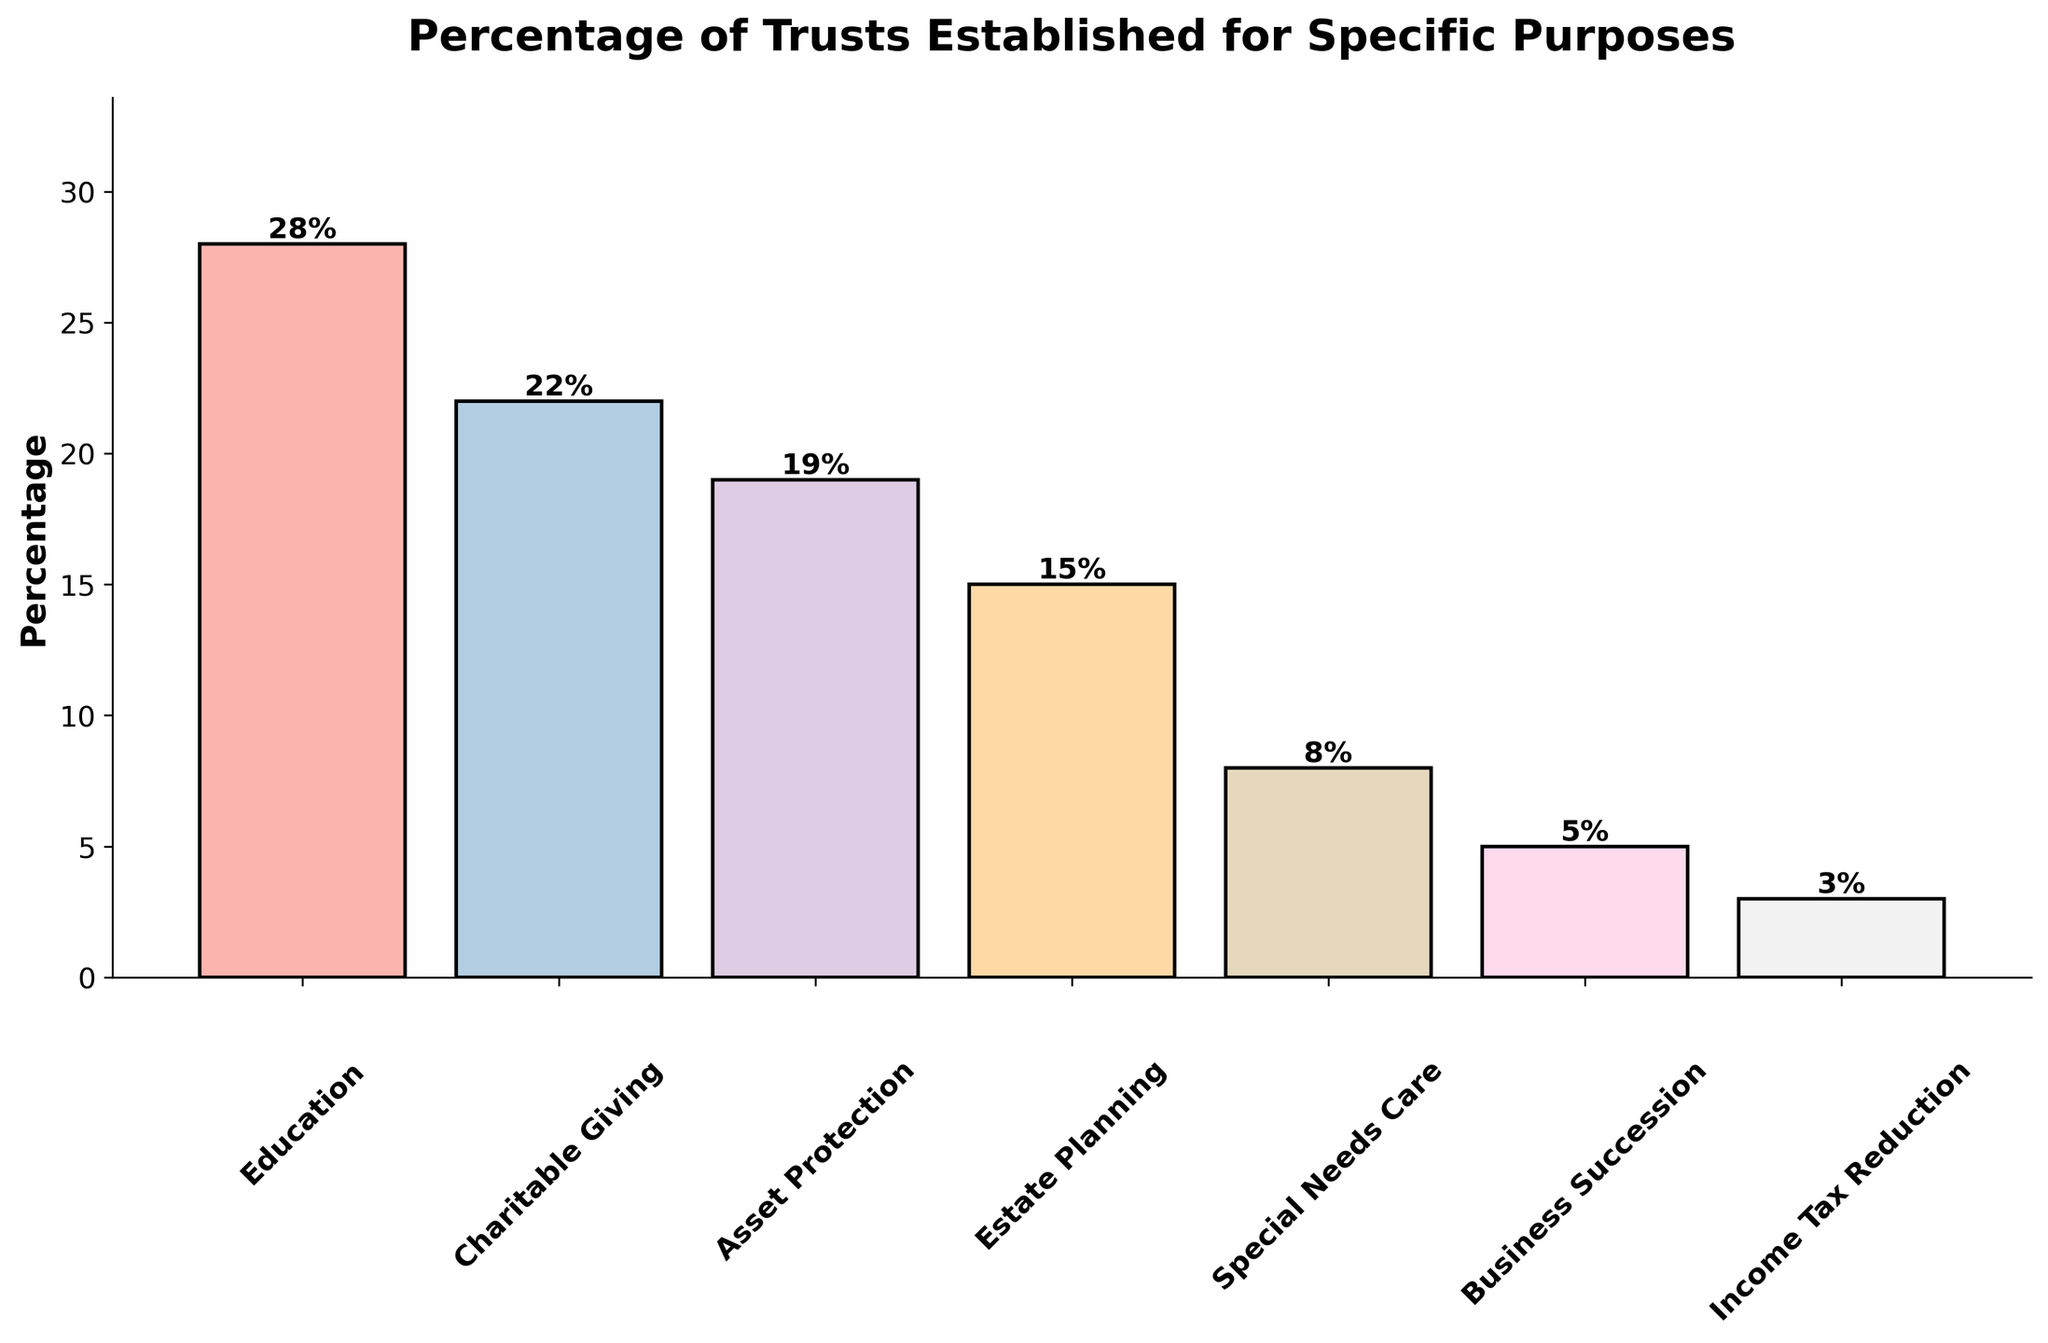What is the most common purpose for which trusts are established? The most common purpose is the one with the highest percentage bar in the figure. The 'Education' bar is the tallest at 28%.
Answer: Education Which trust purpose has the smallest percentage? The smallest percentage is represented by the shortest bar in the figure. The 'Income Tax Reduction' bar is the shortest at 3%.
Answer: Income Tax Reduction Which purpose has a higher percentage, 'Charitable Giving' or 'Special Needs Care'? Compare the heights of the bars for 'Charitable Giving' and 'Special Needs Care'. 'Charitable Giving' has a percentage of 22%, which is higher than 'Special Needs Care' at 8%.
Answer: Charitable Giving What is the combined percentage of 'Education' and 'Asset Protection'? Add the percentages for 'Education' and 'Asset Protection': 28% + 19% = 47%.
Answer: 47% What is the difference in percentage between 'Estate Planning' and 'Business Succession'? Subtract the percentage of 'Business Succession' from 'Estate Planning': 15% - 5% = 10%.
Answer: 10% How many purposes have a percentage of 15% or more? Count the bars with a height of 15% or more: 'Education' (28%), 'Charitable Giving' (22%), 'Asset Protection' (19%), and 'Estate Planning' (15%). Thus, there are 4 purposes.
Answer: 4 If the percentages were arranged in descending order, which purpose would come third? Arrange the percentages in descending order: 28%, 22%, 19%, 15%, 8%, 5%, and 3%. The third highest is 19% corresponding to 'Asset Protection'.
Answer: Asset Protection What is the average percentage of the purposes shown? Sum all percentages and divide by the number of purposes: (28% + 22% + 19% + 15% + 8% + 5% + 3%) / 7 = 100% / 7 ≈ 14.3%.
Answer: 14.3% How many purposes have percentages below 10%? Count the bars with a height below 10%: 'Special Needs Care' (8%), 'Business Succession' (5%), and 'Income Tax Reduction' (3%). Therefore, there are 3 purposes.
Answer: 3 